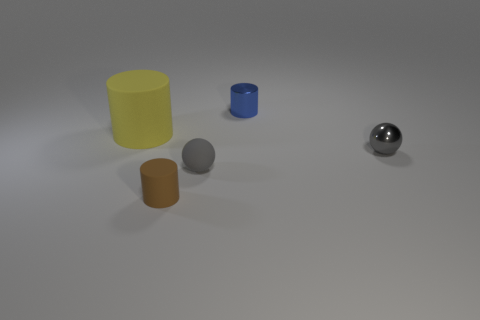There is a shiny thing that is in front of the tiny blue thing; is there a small rubber ball that is behind it?
Keep it short and to the point. No. What color is the shiny thing to the right of the tiny blue metallic cylinder?
Provide a succinct answer. Gray. Are there an equal number of gray metal spheres to the left of the large yellow rubber object and yellow matte things?
Offer a terse response. No. What is the shape of the tiny thing that is both in front of the large yellow object and to the right of the gray rubber object?
Your answer should be very brief. Sphere. The other metallic thing that is the same shape as the large yellow object is what color?
Your response must be concise. Blue. Are there any other things that are the same color as the large rubber thing?
Your response must be concise. No. There is a small brown object in front of the big yellow thing behind the sphere that is left of the metal ball; what is its shape?
Your answer should be very brief. Cylinder. Do the metallic thing that is in front of the yellow rubber cylinder and the metal thing that is behind the small gray metal object have the same size?
Keep it short and to the point. Yes. What number of small yellow blocks have the same material as the tiny brown cylinder?
Keep it short and to the point. 0. What number of large yellow matte things are in front of the matte cylinder in front of the object that is on the left side of the small matte cylinder?
Your answer should be compact. 0. 